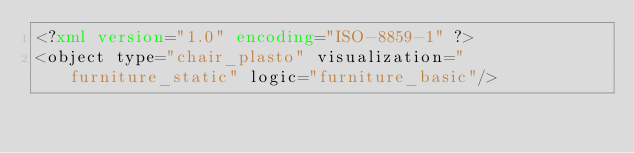Convert code to text. <code><loc_0><loc_0><loc_500><loc_500><_XML_><?xml version="1.0" encoding="ISO-8859-1" ?>
<object type="chair_plasto" visualization="furniture_static" logic="furniture_basic"/>
</code> 